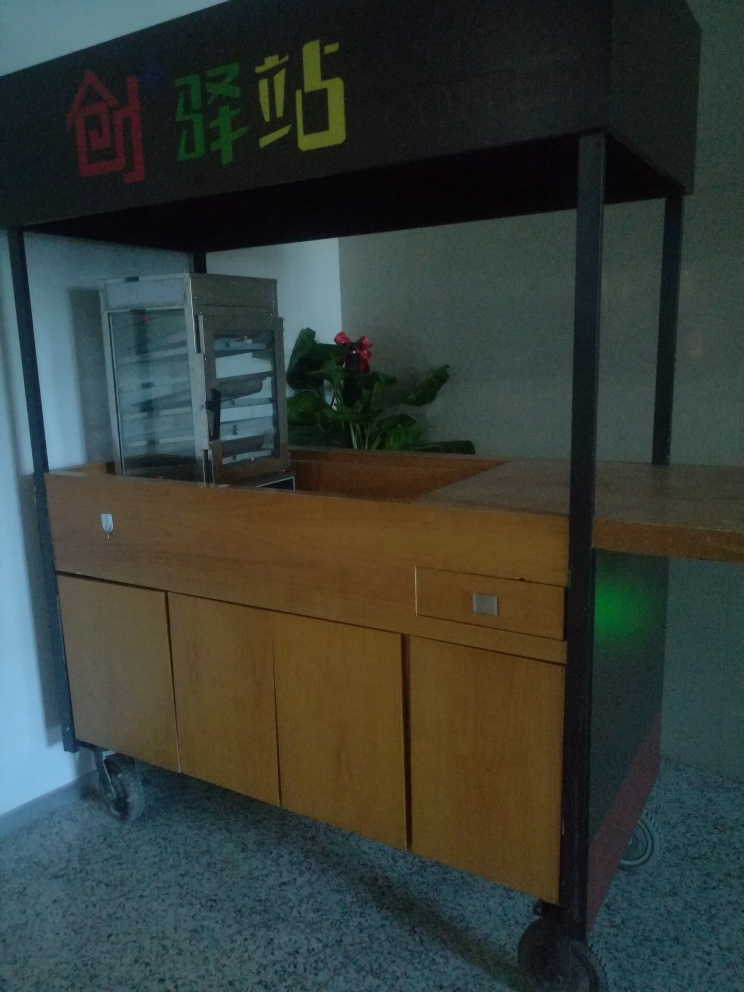Is there a significant amount of grain in the photo? Actually, there doesn't appear to be a significant amount of visual 'grain' or noise in the photo; the image seems relatively clear. It's possible to confuse the speckled pattern on the floor with grain, but upon closer examination, it's clear this is the intended design of the flooring material. 